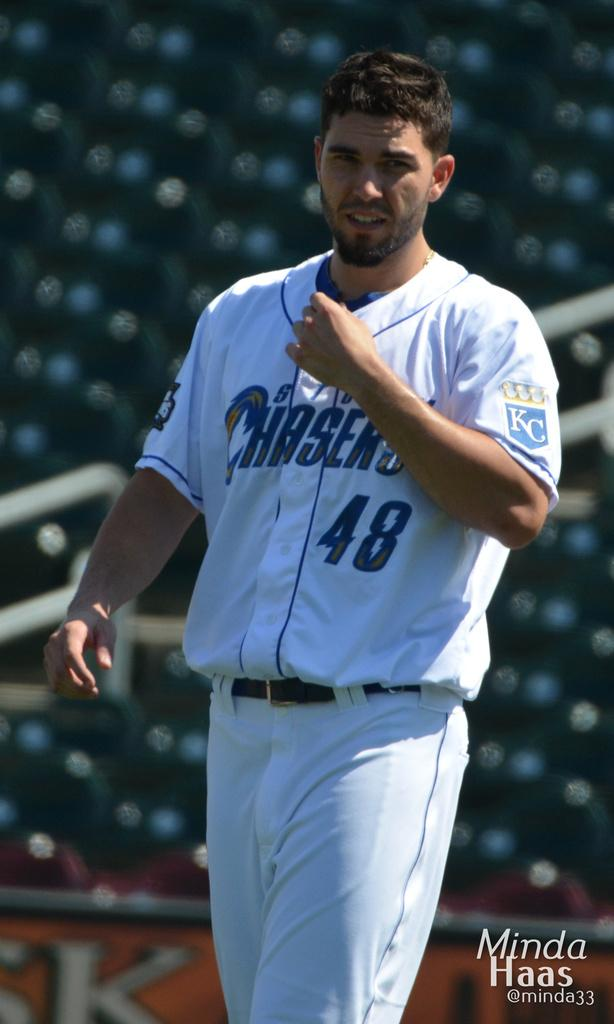Provide a one-sentence caption for the provided image. A Chasers player is standing in a stadium. 